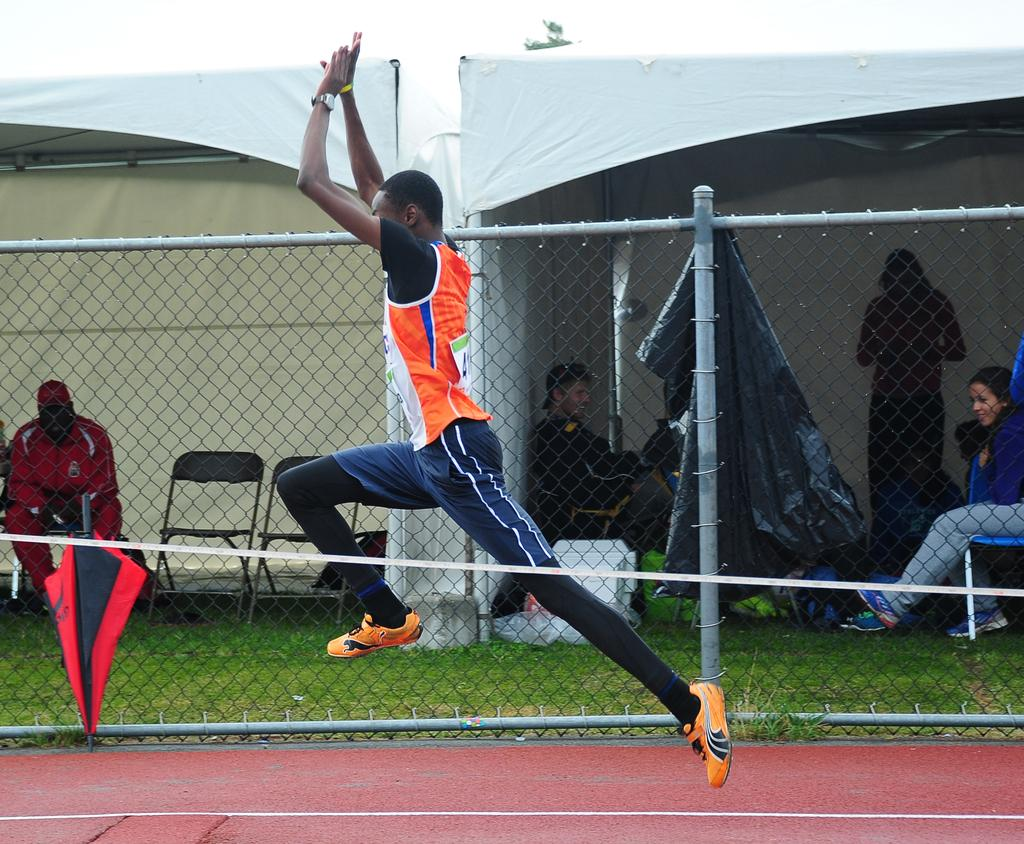What is the person in the image doing? The person is in the air, which suggests they might be flying or jumping. What can be seen below the person in the image? The ground is visible in the image. What object is being used by the person in the air? There is an umbrella in the image, which might be helping the person stay in the air. What type of barrier is present in the image? There is a fence in the image. What type of vegetation is present in the image? Grass is present in the image. What are the people sitting on in the image? There are people sitting on chairs in the image. What type of shelter is present in the image? There is a tent in the image. What is visible in the background of the image? The sky is visible in the background of the image. How many rabbits are hopping around the person in the image? There are no rabbits present in the image. What type of sock is the person wearing while flying with the umbrella? There is no mention of a sock in the image, and the person's feet are not visible. 